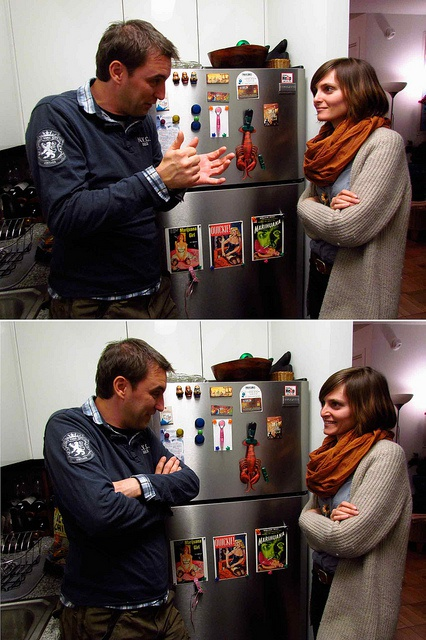Describe the objects in this image and their specific colors. I can see people in lightgray, black, maroon, and gray tones, refrigerator in lightgray, black, gray, and maroon tones, refrigerator in lightgray, black, gray, white, and darkgray tones, people in lightgray, black, maroon, and gray tones, and people in lightgray, black, gray, and maroon tones in this image. 